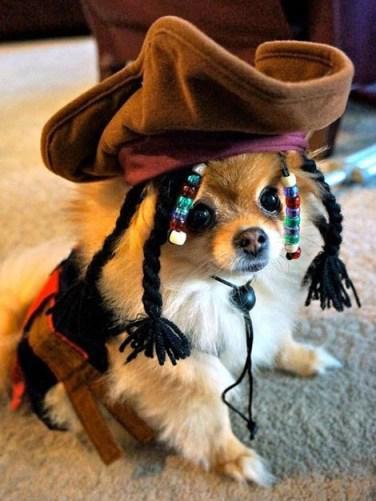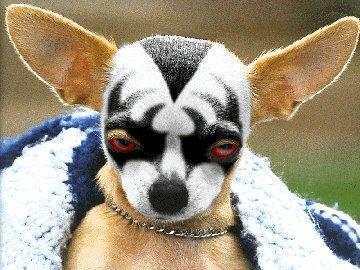The first image is the image on the left, the second image is the image on the right. Given the left and right images, does the statement "A dog wears a hat in at least one image." hold true? Answer yes or no. Yes. The first image is the image on the left, the second image is the image on the right. Evaluate the accuracy of this statement regarding the images: "At least one of the dogs is wearing a hat on it's head.". Is it true? Answer yes or no. Yes. 